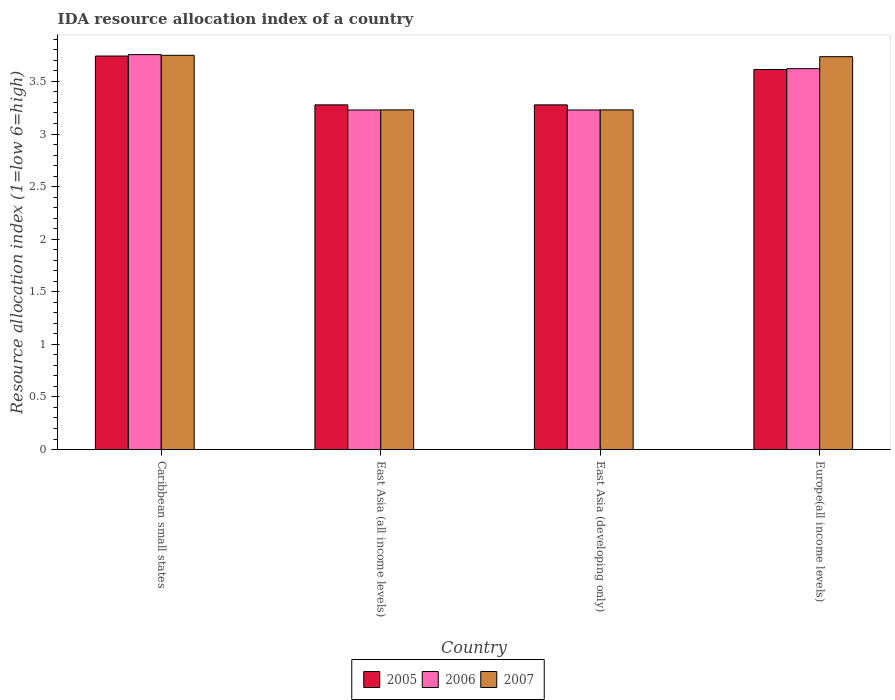Are the number of bars per tick equal to the number of legend labels?
Keep it short and to the point. Yes. Are the number of bars on each tick of the X-axis equal?
Offer a very short reply. Yes. How many bars are there on the 4th tick from the left?
Keep it short and to the point. 3. How many bars are there on the 3rd tick from the right?
Your answer should be very brief. 3. What is the label of the 3rd group of bars from the left?
Offer a very short reply. East Asia (developing only). What is the IDA resource allocation index in 2005 in East Asia (developing only)?
Offer a terse response. 3.28. Across all countries, what is the maximum IDA resource allocation index in 2007?
Keep it short and to the point. 3.75. Across all countries, what is the minimum IDA resource allocation index in 2006?
Your response must be concise. 3.23. In which country was the IDA resource allocation index in 2005 maximum?
Ensure brevity in your answer.  Caribbean small states. In which country was the IDA resource allocation index in 2006 minimum?
Make the answer very short. East Asia (all income levels). What is the total IDA resource allocation index in 2005 in the graph?
Ensure brevity in your answer.  13.91. What is the difference between the IDA resource allocation index in 2005 in East Asia (developing only) and that in Europe(all income levels)?
Ensure brevity in your answer.  -0.34. What is the difference between the IDA resource allocation index in 2007 in Caribbean small states and the IDA resource allocation index in 2005 in East Asia (developing only)?
Ensure brevity in your answer.  0.47. What is the average IDA resource allocation index in 2005 per country?
Make the answer very short. 3.48. What is the difference between the IDA resource allocation index of/in 2005 and IDA resource allocation index of/in 2007 in Caribbean small states?
Ensure brevity in your answer.  -0.01. In how many countries, is the IDA resource allocation index in 2006 greater than 2.6?
Your answer should be compact. 4. What is the ratio of the IDA resource allocation index in 2005 in Caribbean small states to that in Europe(all income levels)?
Offer a very short reply. 1.04. Is the IDA resource allocation index in 2007 in East Asia (developing only) less than that in Europe(all income levels)?
Keep it short and to the point. Yes. What is the difference between the highest and the second highest IDA resource allocation index in 2006?
Your answer should be compact. 0.39. What is the difference between the highest and the lowest IDA resource allocation index in 2005?
Make the answer very short. 0.46. In how many countries, is the IDA resource allocation index in 2005 greater than the average IDA resource allocation index in 2005 taken over all countries?
Give a very brief answer. 2. What does the 1st bar from the left in East Asia (developing only) represents?
Provide a succinct answer. 2005. What does the 1st bar from the right in East Asia (all income levels) represents?
Your answer should be compact. 2007. Is it the case that in every country, the sum of the IDA resource allocation index in 2006 and IDA resource allocation index in 2007 is greater than the IDA resource allocation index in 2005?
Your answer should be very brief. Yes. How many bars are there?
Ensure brevity in your answer.  12. Are all the bars in the graph horizontal?
Your answer should be very brief. No. How many countries are there in the graph?
Your answer should be compact. 4. Where does the legend appear in the graph?
Your response must be concise. Bottom center. How many legend labels are there?
Give a very brief answer. 3. What is the title of the graph?
Provide a short and direct response. IDA resource allocation index of a country. What is the label or title of the X-axis?
Provide a short and direct response. Country. What is the label or title of the Y-axis?
Provide a succinct answer. Resource allocation index (1=low 6=high). What is the Resource allocation index (1=low 6=high) in 2005 in Caribbean small states?
Keep it short and to the point. 3.74. What is the Resource allocation index (1=low 6=high) of 2006 in Caribbean small states?
Ensure brevity in your answer.  3.75. What is the Resource allocation index (1=low 6=high) in 2007 in Caribbean small states?
Make the answer very short. 3.75. What is the Resource allocation index (1=low 6=high) in 2005 in East Asia (all income levels)?
Give a very brief answer. 3.28. What is the Resource allocation index (1=low 6=high) in 2006 in East Asia (all income levels)?
Keep it short and to the point. 3.23. What is the Resource allocation index (1=low 6=high) of 2007 in East Asia (all income levels)?
Make the answer very short. 3.23. What is the Resource allocation index (1=low 6=high) in 2005 in East Asia (developing only)?
Offer a terse response. 3.28. What is the Resource allocation index (1=low 6=high) in 2006 in East Asia (developing only)?
Give a very brief answer. 3.23. What is the Resource allocation index (1=low 6=high) of 2007 in East Asia (developing only)?
Offer a very short reply. 3.23. What is the Resource allocation index (1=low 6=high) in 2005 in Europe(all income levels)?
Ensure brevity in your answer.  3.61. What is the Resource allocation index (1=low 6=high) in 2006 in Europe(all income levels)?
Offer a terse response. 3.62. What is the Resource allocation index (1=low 6=high) in 2007 in Europe(all income levels)?
Provide a short and direct response. 3.74. Across all countries, what is the maximum Resource allocation index (1=low 6=high) in 2005?
Provide a short and direct response. 3.74. Across all countries, what is the maximum Resource allocation index (1=low 6=high) in 2006?
Offer a terse response. 3.75. Across all countries, what is the maximum Resource allocation index (1=low 6=high) in 2007?
Provide a succinct answer. 3.75. Across all countries, what is the minimum Resource allocation index (1=low 6=high) of 2005?
Your response must be concise. 3.28. Across all countries, what is the minimum Resource allocation index (1=low 6=high) of 2006?
Provide a succinct answer. 3.23. Across all countries, what is the minimum Resource allocation index (1=low 6=high) of 2007?
Your response must be concise. 3.23. What is the total Resource allocation index (1=low 6=high) of 2005 in the graph?
Provide a short and direct response. 13.91. What is the total Resource allocation index (1=low 6=high) of 2006 in the graph?
Keep it short and to the point. 13.83. What is the total Resource allocation index (1=low 6=high) of 2007 in the graph?
Ensure brevity in your answer.  13.94. What is the difference between the Resource allocation index (1=low 6=high) in 2005 in Caribbean small states and that in East Asia (all income levels)?
Give a very brief answer. 0.46. What is the difference between the Resource allocation index (1=low 6=high) in 2006 in Caribbean small states and that in East Asia (all income levels)?
Your answer should be very brief. 0.53. What is the difference between the Resource allocation index (1=low 6=high) of 2007 in Caribbean small states and that in East Asia (all income levels)?
Make the answer very short. 0.52. What is the difference between the Resource allocation index (1=low 6=high) of 2005 in Caribbean small states and that in East Asia (developing only)?
Ensure brevity in your answer.  0.46. What is the difference between the Resource allocation index (1=low 6=high) in 2006 in Caribbean small states and that in East Asia (developing only)?
Your answer should be compact. 0.53. What is the difference between the Resource allocation index (1=low 6=high) of 2007 in Caribbean small states and that in East Asia (developing only)?
Your answer should be compact. 0.52. What is the difference between the Resource allocation index (1=low 6=high) in 2005 in Caribbean small states and that in Europe(all income levels)?
Your answer should be very brief. 0.13. What is the difference between the Resource allocation index (1=low 6=high) in 2006 in Caribbean small states and that in Europe(all income levels)?
Offer a terse response. 0.13. What is the difference between the Resource allocation index (1=low 6=high) of 2007 in Caribbean small states and that in Europe(all income levels)?
Your answer should be very brief. 0.01. What is the difference between the Resource allocation index (1=low 6=high) of 2005 in East Asia (all income levels) and that in Europe(all income levels)?
Make the answer very short. -0.34. What is the difference between the Resource allocation index (1=low 6=high) of 2006 in East Asia (all income levels) and that in Europe(all income levels)?
Ensure brevity in your answer.  -0.39. What is the difference between the Resource allocation index (1=low 6=high) of 2007 in East Asia (all income levels) and that in Europe(all income levels)?
Provide a short and direct response. -0.51. What is the difference between the Resource allocation index (1=low 6=high) of 2005 in East Asia (developing only) and that in Europe(all income levels)?
Offer a terse response. -0.34. What is the difference between the Resource allocation index (1=low 6=high) of 2006 in East Asia (developing only) and that in Europe(all income levels)?
Keep it short and to the point. -0.39. What is the difference between the Resource allocation index (1=low 6=high) in 2007 in East Asia (developing only) and that in Europe(all income levels)?
Make the answer very short. -0.51. What is the difference between the Resource allocation index (1=low 6=high) in 2005 in Caribbean small states and the Resource allocation index (1=low 6=high) in 2006 in East Asia (all income levels)?
Your response must be concise. 0.51. What is the difference between the Resource allocation index (1=low 6=high) in 2005 in Caribbean small states and the Resource allocation index (1=low 6=high) in 2007 in East Asia (all income levels)?
Your response must be concise. 0.51. What is the difference between the Resource allocation index (1=low 6=high) of 2006 in Caribbean small states and the Resource allocation index (1=low 6=high) of 2007 in East Asia (all income levels)?
Make the answer very short. 0.53. What is the difference between the Resource allocation index (1=low 6=high) in 2005 in Caribbean small states and the Resource allocation index (1=low 6=high) in 2006 in East Asia (developing only)?
Your answer should be compact. 0.51. What is the difference between the Resource allocation index (1=low 6=high) in 2005 in Caribbean small states and the Resource allocation index (1=low 6=high) in 2007 in East Asia (developing only)?
Keep it short and to the point. 0.51. What is the difference between the Resource allocation index (1=low 6=high) in 2006 in Caribbean small states and the Resource allocation index (1=low 6=high) in 2007 in East Asia (developing only)?
Offer a terse response. 0.53. What is the difference between the Resource allocation index (1=low 6=high) of 2005 in Caribbean small states and the Resource allocation index (1=low 6=high) of 2006 in Europe(all income levels)?
Your answer should be very brief. 0.12. What is the difference between the Resource allocation index (1=low 6=high) of 2005 in Caribbean small states and the Resource allocation index (1=low 6=high) of 2007 in Europe(all income levels)?
Your response must be concise. 0.01. What is the difference between the Resource allocation index (1=low 6=high) in 2006 in Caribbean small states and the Resource allocation index (1=low 6=high) in 2007 in Europe(all income levels)?
Ensure brevity in your answer.  0.02. What is the difference between the Resource allocation index (1=low 6=high) in 2005 in East Asia (all income levels) and the Resource allocation index (1=low 6=high) in 2006 in East Asia (developing only)?
Provide a short and direct response. 0.05. What is the difference between the Resource allocation index (1=low 6=high) in 2005 in East Asia (all income levels) and the Resource allocation index (1=low 6=high) in 2007 in East Asia (developing only)?
Give a very brief answer. 0.05. What is the difference between the Resource allocation index (1=low 6=high) in 2006 in East Asia (all income levels) and the Resource allocation index (1=low 6=high) in 2007 in East Asia (developing only)?
Offer a terse response. -0. What is the difference between the Resource allocation index (1=low 6=high) of 2005 in East Asia (all income levels) and the Resource allocation index (1=low 6=high) of 2006 in Europe(all income levels)?
Keep it short and to the point. -0.34. What is the difference between the Resource allocation index (1=low 6=high) in 2005 in East Asia (all income levels) and the Resource allocation index (1=low 6=high) in 2007 in Europe(all income levels)?
Ensure brevity in your answer.  -0.46. What is the difference between the Resource allocation index (1=low 6=high) in 2006 in East Asia (all income levels) and the Resource allocation index (1=low 6=high) in 2007 in Europe(all income levels)?
Keep it short and to the point. -0.51. What is the difference between the Resource allocation index (1=low 6=high) in 2005 in East Asia (developing only) and the Resource allocation index (1=low 6=high) in 2006 in Europe(all income levels)?
Offer a very short reply. -0.34. What is the difference between the Resource allocation index (1=low 6=high) in 2005 in East Asia (developing only) and the Resource allocation index (1=low 6=high) in 2007 in Europe(all income levels)?
Offer a terse response. -0.46. What is the difference between the Resource allocation index (1=low 6=high) of 2006 in East Asia (developing only) and the Resource allocation index (1=low 6=high) of 2007 in Europe(all income levels)?
Your answer should be compact. -0.51. What is the average Resource allocation index (1=low 6=high) in 2005 per country?
Your response must be concise. 3.48. What is the average Resource allocation index (1=low 6=high) in 2006 per country?
Keep it short and to the point. 3.46. What is the average Resource allocation index (1=low 6=high) in 2007 per country?
Give a very brief answer. 3.49. What is the difference between the Resource allocation index (1=low 6=high) of 2005 and Resource allocation index (1=low 6=high) of 2006 in Caribbean small states?
Provide a succinct answer. -0.01. What is the difference between the Resource allocation index (1=low 6=high) of 2005 and Resource allocation index (1=low 6=high) of 2007 in Caribbean small states?
Offer a terse response. -0.01. What is the difference between the Resource allocation index (1=low 6=high) of 2006 and Resource allocation index (1=low 6=high) of 2007 in Caribbean small states?
Give a very brief answer. 0.01. What is the difference between the Resource allocation index (1=low 6=high) of 2005 and Resource allocation index (1=low 6=high) of 2006 in East Asia (all income levels)?
Offer a terse response. 0.05. What is the difference between the Resource allocation index (1=low 6=high) of 2005 and Resource allocation index (1=low 6=high) of 2007 in East Asia (all income levels)?
Provide a short and direct response. 0.05. What is the difference between the Resource allocation index (1=low 6=high) in 2006 and Resource allocation index (1=low 6=high) in 2007 in East Asia (all income levels)?
Your answer should be compact. -0. What is the difference between the Resource allocation index (1=low 6=high) of 2005 and Resource allocation index (1=low 6=high) of 2006 in East Asia (developing only)?
Provide a short and direct response. 0.05. What is the difference between the Resource allocation index (1=low 6=high) of 2005 and Resource allocation index (1=low 6=high) of 2007 in East Asia (developing only)?
Provide a succinct answer. 0.05. What is the difference between the Resource allocation index (1=low 6=high) in 2006 and Resource allocation index (1=low 6=high) in 2007 in East Asia (developing only)?
Provide a succinct answer. -0. What is the difference between the Resource allocation index (1=low 6=high) of 2005 and Resource allocation index (1=low 6=high) of 2006 in Europe(all income levels)?
Offer a terse response. -0.01. What is the difference between the Resource allocation index (1=low 6=high) of 2005 and Resource allocation index (1=low 6=high) of 2007 in Europe(all income levels)?
Your response must be concise. -0.12. What is the difference between the Resource allocation index (1=low 6=high) in 2006 and Resource allocation index (1=low 6=high) in 2007 in Europe(all income levels)?
Give a very brief answer. -0.11. What is the ratio of the Resource allocation index (1=low 6=high) in 2005 in Caribbean small states to that in East Asia (all income levels)?
Provide a succinct answer. 1.14. What is the ratio of the Resource allocation index (1=low 6=high) in 2006 in Caribbean small states to that in East Asia (all income levels)?
Offer a terse response. 1.16. What is the ratio of the Resource allocation index (1=low 6=high) of 2007 in Caribbean small states to that in East Asia (all income levels)?
Your answer should be very brief. 1.16. What is the ratio of the Resource allocation index (1=low 6=high) of 2005 in Caribbean small states to that in East Asia (developing only)?
Ensure brevity in your answer.  1.14. What is the ratio of the Resource allocation index (1=low 6=high) in 2006 in Caribbean small states to that in East Asia (developing only)?
Your response must be concise. 1.16. What is the ratio of the Resource allocation index (1=low 6=high) of 2007 in Caribbean small states to that in East Asia (developing only)?
Give a very brief answer. 1.16. What is the ratio of the Resource allocation index (1=low 6=high) in 2005 in Caribbean small states to that in Europe(all income levels)?
Your response must be concise. 1.04. What is the ratio of the Resource allocation index (1=low 6=high) in 2006 in Caribbean small states to that in Europe(all income levels)?
Make the answer very short. 1.04. What is the ratio of the Resource allocation index (1=low 6=high) in 2005 in East Asia (all income levels) to that in East Asia (developing only)?
Make the answer very short. 1. What is the ratio of the Resource allocation index (1=low 6=high) in 2006 in East Asia (all income levels) to that in East Asia (developing only)?
Ensure brevity in your answer.  1. What is the ratio of the Resource allocation index (1=low 6=high) of 2005 in East Asia (all income levels) to that in Europe(all income levels)?
Give a very brief answer. 0.91. What is the ratio of the Resource allocation index (1=low 6=high) of 2006 in East Asia (all income levels) to that in Europe(all income levels)?
Provide a succinct answer. 0.89. What is the ratio of the Resource allocation index (1=low 6=high) in 2007 in East Asia (all income levels) to that in Europe(all income levels)?
Your answer should be compact. 0.86. What is the ratio of the Resource allocation index (1=low 6=high) in 2005 in East Asia (developing only) to that in Europe(all income levels)?
Keep it short and to the point. 0.91. What is the ratio of the Resource allocation index (1=low 6=high) of 2006 in East Asia (developing only) to that in Europe(all income levels)?
Offer a very short reply. 0.89. What is the ratio of the Resource allocation index (1=low 6=high) in 2007 in East Asia (developing only) to that in Europe(all income levels)?
Make the answer very short. 0.86. What is the difference between the highest and the second highest Resource allocation index (1=low 6=high) of 2005?
Provide a succinct answer. 0.13. What is the difference between the highest and the second highest Resource allocation index (1=low 6=high) in 2006?
Provide a succinct answer. 0.13. What is the difference between the highest and the second highest Resource allocation index (1=low 6=high) of 2007?
Your response must be concise. 0.01. What is the difference between the highest and the lowest Resource allocation index (1=low 6=high) in 2005?
Your answer should be very brief. 0.46. What is the difference between the highest and the lowest Resource allocation index (1=low 6=high) of 2006?
Keep it short and to the point. 0.53. What is the difference between the highest and the lowest Resource allocation index (1=low 6=high) in 2007?
Provide a succinct answer. 0.52. 